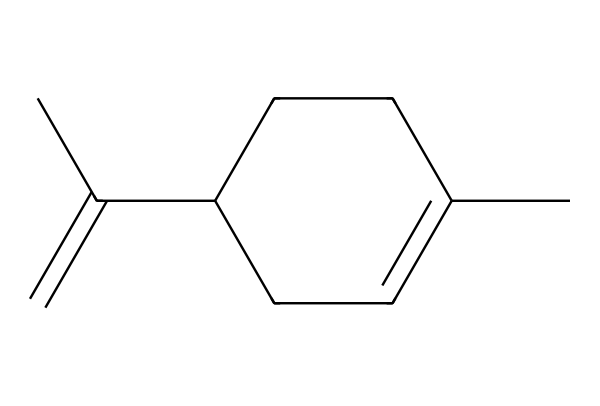How many carbon atoms are in limonene? By analyzing the SMILES representation, CC1=CCC(CC1)C(=C)C, we can count the carbon atoms. There are 10 carbon atoms in total in this structure.
Answer: 10 What type of bonds are present in limonene? The SMILES format indicates both single and double bonds. The presence of the "=" symbol indicates there are double bonds, while the absence indicates single bonds. Therefore, limonene has both single and double bonds.
Answer: single and double How many double bonds does limonene have? Analyzing the SMILES, CC1=CCC(CC1)C(=C)C, we identify the "=" symbols which indicate double bonds. There are two double bonds in this structure.
Answer: 2 Is limonene a cyclic compound? To determine if limonene is cyclic, I look at the structure noting the "C1" which indicates the start of a ring and "CC1" which indicates it closes the ring. Therefore, limonene is a cyclic compound.
Answer: yes What functional group is associated with limonene? In limonene, the absence of hydroxyl (-OH) or carboxyl (-COOH) groups indicates that it does not contain those common functional groups and is primarily a hydrocarbon, highlighting its classification as a terpene.
Answer: hydrocarbon What characteristic smell does limonene have? Limonene is known for its citrus scent, specifically reminiscent of oranges and lemons. This is a defining characteristic of its essence and usage in scents and cleaning products.
Answer: citrus 